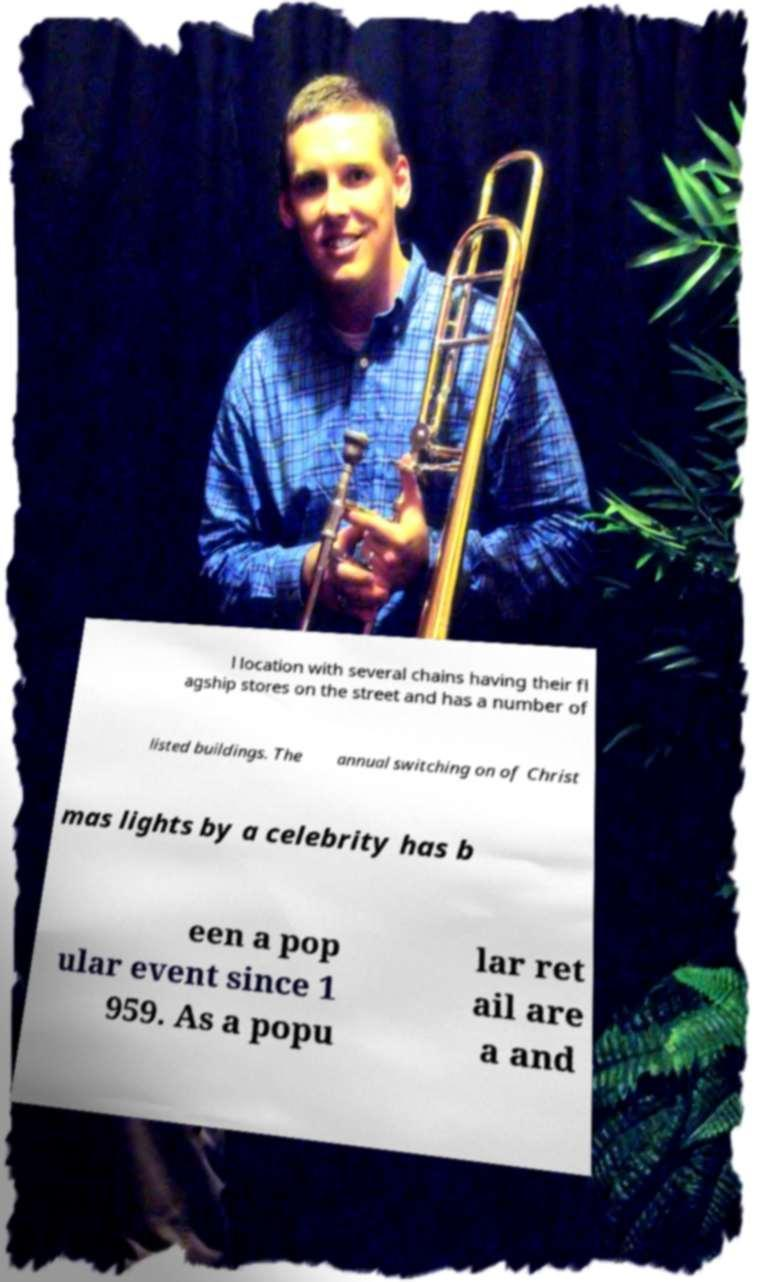Please read and relay the text visible in this image. What does it say? l location with several chains having their fl agship stores on the street and has a number of listed buildings. The annual switching on of Christ mas lights by a celebrity has b een a pop ular event since 1 959. As a popu lar ret ail are a and 